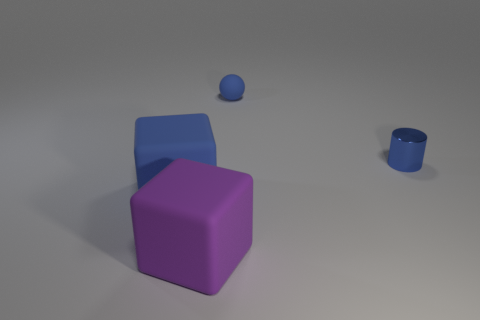Add 2 blue shiny things. How many objects exist? 6 Subtract all cylinders. How many objects are left? 3 Subtract 1 balls. How many balls are left? 0 Subtract all brown cylinders. Subtract all brown cubes. How many cylinders are left? 1 Subtract all cubes. Subtract all blue matte objects. How many objects are left? 0 Add 3 large blue cubes. How many large blue cubes are left? 4 Add 1 large blue objects. How many large blue objects exist? 2 Subtract 1 blue cubes. How many objects are left? 3 